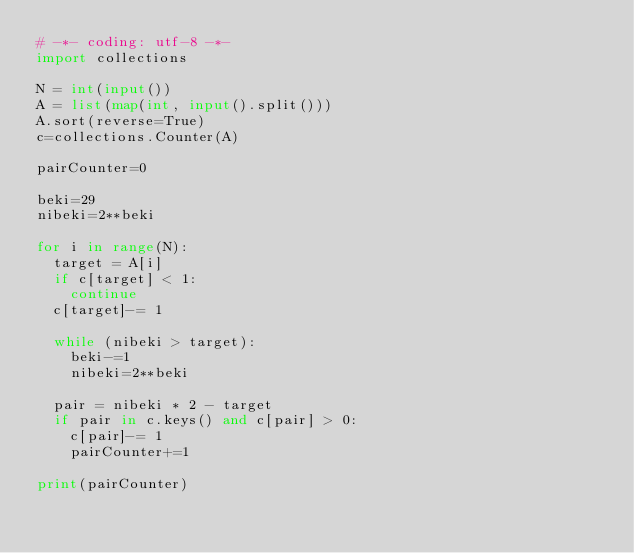<code> <loc_0><loc_0><loc_500><loc_500><_Python_># -*- coding: utf-8 -*-
import collections

N = int(input())
A = list(map(int, input().split()))
A.sort(reverse=True)
c=collections.Counter(A)

pairCounter=0

beki=29
nibeki=2**beki

for i in range(N):
  target = A[i]
  if c[target] < 1:
    continue
  c[target]-= 1

  while (nibeki > target):
    beki-=1
    nibeki=2**beki

  pair = nibeki * 2 - target
  if pair in c.keys() and c[pair] > 0:
    c[pair]-= 1
    pairCounter+=1

print(pairCounter)</code> 